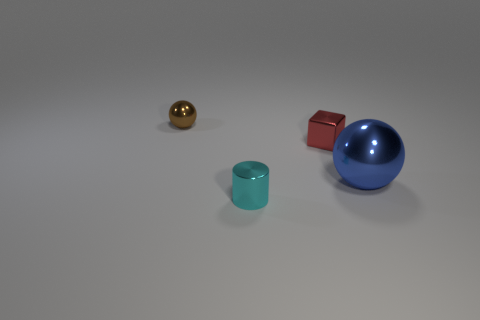Add 2 tiny brown spheres. How many objects exist? 6 Subtract all blocks. How many objects are left? 3 Subtract 0 yellow cubes. How many objects are left? 4 Subtract all blue things. Subtract all large blue shiny things. How many objects are left? 2 Add 3 spheres. How many spheres are left? 5 Add 3 small purple metallic spheres. How many small purple metallic spheres exist? 3 